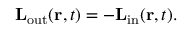Convert formula to latex. <formula><loc_0><loc_0><loc_500><loc_500>L _ { o u t } ( r , t ) = - L _ { i n } ( r , t ) .</formula> 